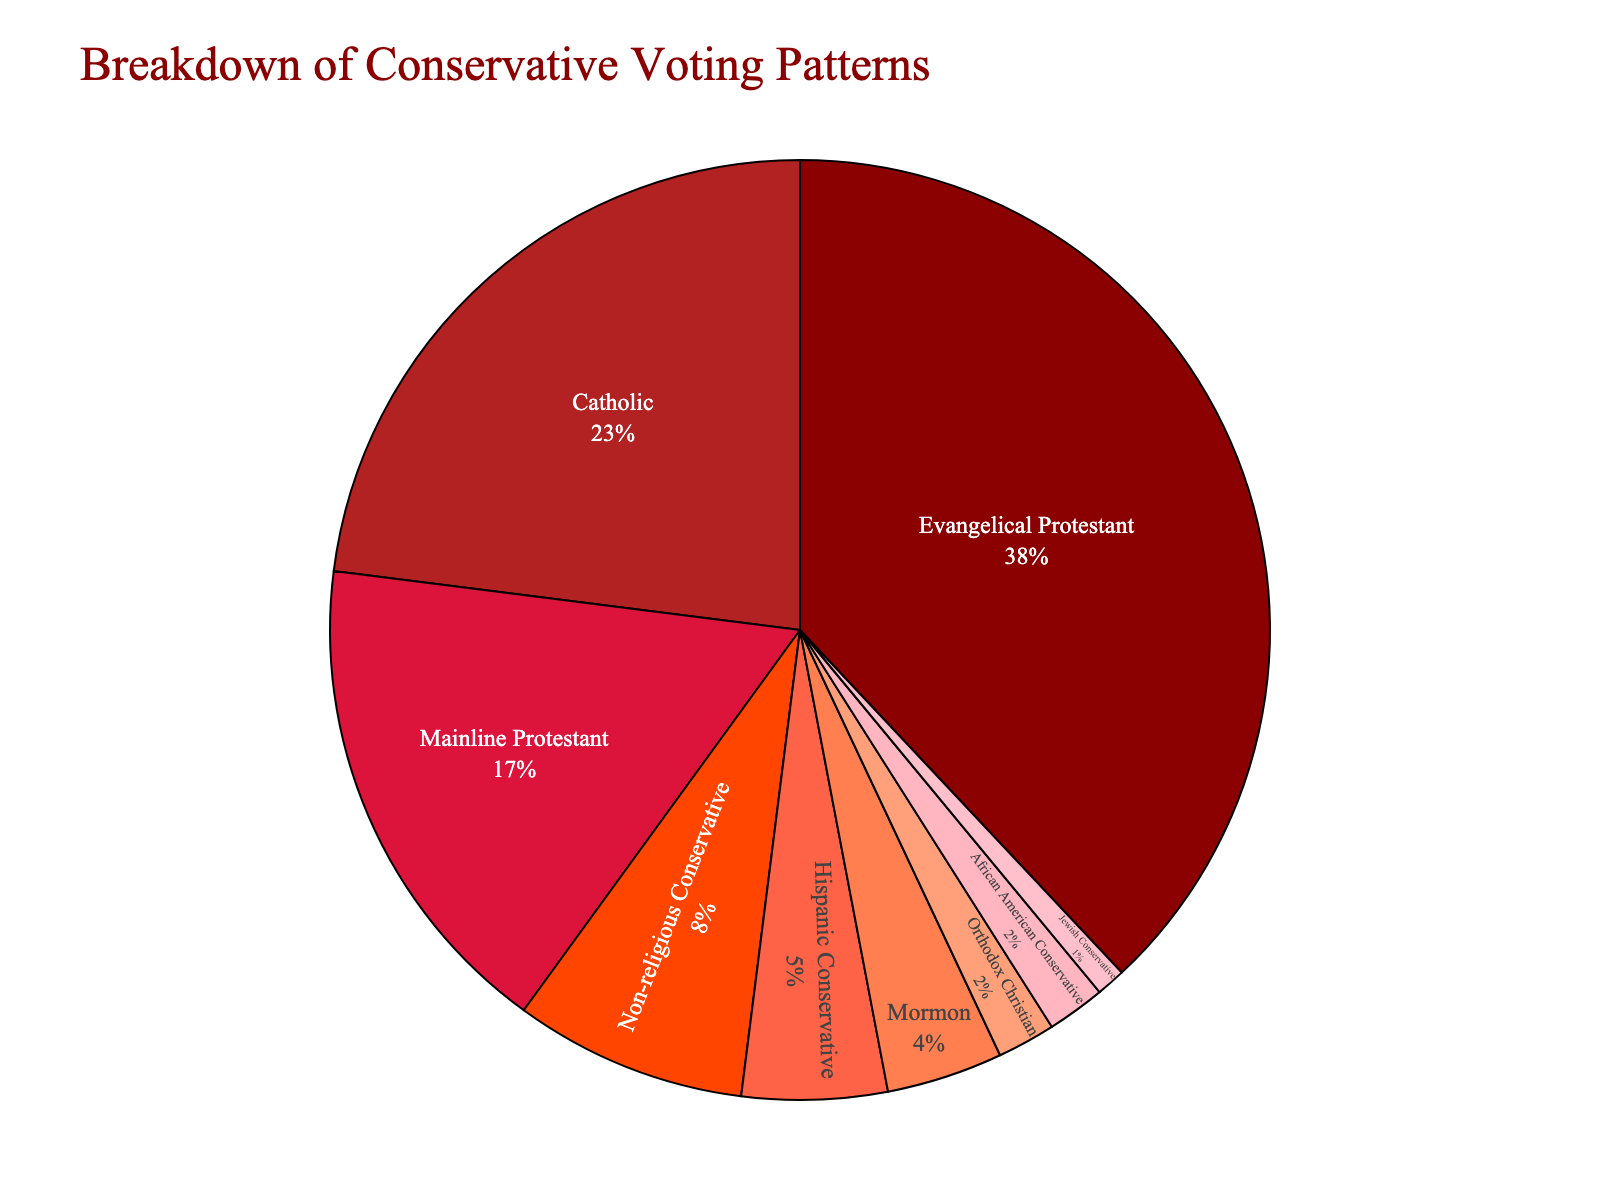Which group has the highest percentage of conservative voters? The pie chart shows the segments of conservative voters, and the largest segment is labeled "Evangelical Protestant" with a percentage of 38.
Answer: Evangelical Protestant Which group has the second-highest percentage of conservative voters? By looking at the size of the different segments, the second-largest segment is labeled "Catholic" with a percentage of 23.
Answer: Catholic What is the combined percentage of Evangelical Protestant and Catholic conservative voters? The percentage for Evangelical Protestant is 38% and for Catholic is 23%. Adding them together gives 38 + 23 = 61.
Answer: 61% How much more significant is the percentage of Evangelical Protestant conservative voters compared to Non-religious Conservative voters? The percentage for Evangelical Protestant is 38%, and for Non-religious Conservative, it is 8%. The difference is 38 - 8 = 30.
Answer: 30% Which groups have less than 5% of conservative voters? The segments with less than 5% are clearly labeled "Mormon," "Orthodox Christian," "Jewish Conservative," and "African American Conservative" with percentages of 4, 2, 1, and 2, respectively.
Answer: Mormon, Orthodox Christian, Jewish Conservative, African American Conservative What is the total percentage of conservative voters in all groups with percentages lower than 8%? Summing up the percentages for Mormon (4), Orthodox Christian (2), Jewish Conservative (1), Hispanic Conservative (5), and African American Conservative (2) gives 4 + 2 + 1 + 5 + 2 = 14.
Answer: 14% Which group has a red-colored segment and accounts for 5% of conservative voters? By observing the colors and corresponding labels, the "Hispanic Conservative" group has a red-colored segment and is marked with 5%.
Answer: Hispanic Conservative How does the percentage of Mainline Protestant conservative voters compare to that of Hispanic Conservative voters? The pie chart shows that Mainline Protestant accounts for 17%, while Hispanic Conservative accounts for 5%. 17% is larger than 5%.
Answer: Mainline Protestant is larger If you add up the percentages of Evangelical Protestant, Catholic, and Mainline Protestant conservative voters, what is the total? Adding the percentages for Evangelical Protestant (38), Catholic (23), and Mainline Protestant (17) gives 38 + 23 + 17 = 78.
Answer: 78% 